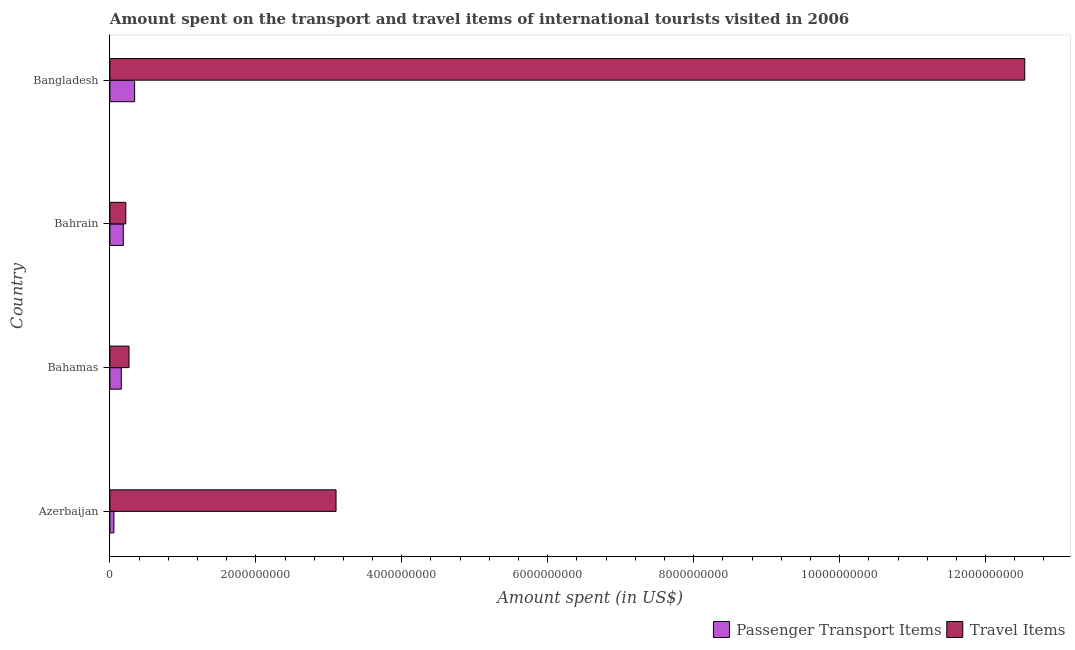How many groups of bars are there?
Provide a short and direct response. 4. Are the number of bars on each tick of the Y-axis equal?
Give a very brief answer. Yes. How many bars are there on the 3rd tick from the top?
Offer a very short reply. 2. How many bars are there on the 3rd tick from the bottom?
Your answer should be very brief. 2. What is the label of the 4th group of bars from the top?
Offer a terse response. Azerbaijan. What is the amount spent on passenger transport items in Bahamas?
Your answer should be very brief. 1.56e+08. Across all countries, what is the maximum amount spent in travel items?
Offer a very short reply. 1.25e+1. Across all countries, what is the minimum amount spent in travel items?
Keep it short and to the point. 2.18e+08. In which country was the amount spent on passenger transport items minimum?
Keep it short and to the point. Azerbaijan. What is the total amount spent on passenger transport items in the graph?
Your answer should be very brief. 7.34e+08. What is the difference between the amount spent in travel items in Azerbaijan and that in Bahamas?
Offer a terse response. 2.84e+09. What is the difference between the amount spent in travel items in Bangladesh and the amount spent on passenger transport items in Bahamas?
Keep it short and to the point. 1.24e+1. What is the average amount spent in travel items per country?
Ensure brevity in your answer.  4.03e+09. What is the difference between the amount spent on passenger transport items and amount spent in travel items in Bahrain?
Give a very brief answer. -3.40e+07. What is the ratio of the amount spent in travel items in Bahamas to that in Bangladesh?
Your answer should be very brief. 0.02. Is the amount spent in travel items in Azerbaijan less than that in Bahamas?
Your response must be concise. No. Is the difference between the amount spent in travel items in Bahamas and Bangladesh greater than the difference between the amount spent on passenger transport items in Bahamas and Bangladesh?
Offer a very short reply. No. What is the difference between the highest and the second highest amount spent in travel items?
Your answer should be very brief. 9.44e+09. What is the difference between the highest and the lowest amount spent on passenger transport items?
Ensure brevity in your answer.  2.84e+08. Is the sum of the amount spent in travel items in Azerbaijan and Bahamas greater than the maximum amount spent on passenger transport items across all countries?
Your answer should be compact. Yes. What does the 1st bar from the top in Bahrain represents?
Provide a short and direct response. Travel Items. What does the 2nd bar from the bottom in Azerbaijan represents?
Your response must be concise. Travel Items. Are all the bars in the graph horizontal?
Ensure brevity in your answer.  Yes. What is the difference between two consecutive major ticks on the X-axis?
Keep it short and to the point. 2.00e+09. Does the graph contain grids?
Provide a succinct answer. No. How are the legend labels stacked?
Make the answer very short. Horizontal. What is the title of the graph?
Provide a succinct answer. Amount spent on the transport and travel items of international tourists visited in 2006. What is the label or title of the X-axis?
Ensure brevity in your answer.  Amount spent (in US$). What is the label or title of the Y-axis?
Your answer should be very brief. Country. What is the Amount spent (in US$) of Passenger Transport Items in Azerbaijan?
Offer a terse response. 5.50e+07. What is the Amount spent (in US$) of Travel Items in Azerbaijan?
Offer a very short reply. 3.10e+09. What is the Amount spent (in US$) in Passenger Transport Items in Bahamas?
Make the answer very short. 1.56e+08. What is the Amount spent (in US$) of Travel Items in Bahamas?
Offer a terse response. 2.62e+08. What is the Amount spent (in US$) in Passenger Transport Items in Bahrain?
Provide a short and direct response. 1.84e+08. What is the Amount spent (in US$) in Travel Items in Bahrain?
Keep it short and to the point. 2.18e+08. What is the Amount spent (in US$) of Passenger Transport Items in Bangladesh?
Make the answer very short. 3.39e+08. What is the Amount spent (in US$) of Travel Items in Bangladesh?
Ensure brevity in your answer.  1.25e+1. Across all countries, what is the maximum Amount spent (in US$) in Passenger Transport Items?
Ensure brevity in your answer.  3.39e+08. Across all countries, what is the maximum Amount spent (in US$) of Travel Items?
Ensure brevity in your answer.  1.25e+1. Across all countries, what is the minimum Amount spent (in US$) of Passenger Transport Items?
Provide a succinct answer. 5.50e+07. Across all countries, what is the minimum Amount spent (in US$) in Travel Items?
Your answer should be compact. 2.18e+08. What is the total Amount spent (in US$) in Passenger Transport Items in the graph?
Give a very brief answer. 7.34e+08. What is the total Amount spent (in US$) of Travel Items in the graph?
Give a very brief answer. 1.61e+1. What is the difference between the Amount spent (in US$) of Passenger Transport Items in Azerbaijan and that in Bahamas?
Your answer should be very brief. -1.01e+08. What is the difference between the Amount spent (in US$) of Travel Items in Azerbaijan and that in Bahamas?
Provide a short and direct response. 2.84e+09. What is the difference between the Amount spent (in US$) in Passenger Transport Items in Azerbaijan and that in Bahrain?
Offer a very short reply. -1.29e+08. What is the difference between the Amount spent (in US$) of Travel Items in Azerbaijan and that in Bahrain?
Your answer should be compact. 2.88e+09. What is the difference between the Amount spent (in US$) of Passenger Transport Items in Azerbaijan and that in Bangladesh?
Your answer should be compact. -2.84e+08. What is the difference between the Amount spent (in US$) of Travel Items in Azerbaijan and that in Bangladesh?
Keep it short and to the point. -9.44e+09. What is the difference between the Amount spent (in US$) in Passenger Transport Items in Bahamas and that in Bahrain?
Your answer should be compact. -2.80e+07. What is the difference between the Amount spent (in US$) of Travel Items in Bahamas and that in Bahrain?
Provide a short and direct response. 4.40e+07. What is the difference between the Amount spent (in US$) in Passenger Transport Items in Bahamas and that in Bangladesh?
Offer a very short reply. -1.83e+08. What is the difference between the Amount spent (in US$) of Travel Items in Bahamas and that in Bangladesh?
Provide a succinct answer. -1.23e+1. What is the difference between the Amount spent (in US$) in Passenger Transport Items in Bahrain and that in Bangladesh?
Make the answer very short. -1.55e+08. What is the difference between the Amount spent (in US$) of Travel Items in Bahrain and that in Bangladesh?
Offer a terse response. -1.23e+1. What is the difference between the Amount spent (in US$) of Passenger Transport Items in Azerbaijan and the Amount spent (in US$) of Travel Items in Bahamas?
Provide a short and direct response. -2.07e+08. What is the difference between the Amount spent (in US$) in Passenger Transport Items in Azerbaijan and the Amount spent (in US$) in Travel Items in Bahrain?
Your response must be concise. -1.63e+08. What is the difference between the Amount spent (in US$) of Passenger Transport Items in Azerbaijan and the Amount spent (in US$) of Travel Items in Bangladesh?
Keep it short and to the point. -1.25e+1. What is the difference between the Amount spent (in US$) in Passenger Transport Items in Bahamas and the Amount spent (in US$) in Travel Items in Bahrain?
Keep it short and to the point. -6.20e+07. What is the difference between the Amount spent (in US$) of Passenger Transport Items in Bahamas and the Amount spent (in US$) of Travel Items in Bangladesh?
Give a very brief answer. -1.24e+1. What is the difference between the Amount spent (in US$) in Passenger Transport Items in Bahrain and the Amount spent (in US$) in Travel Items in Bangladesh?
Give a very brief answer. -1.24e+1. What is the average Amount spent (in US$) in Passenger Transport Items per country?
Your answer should be very brief. 1.84e+08. What is the average Amount spent (in US$) in Travel Items per country?
Your answer should be compact. 4.03e+09. What is the difference between the Amount spent (in US$) in Passenger Transport Items and Amount spent (in US$) in Travel Items in Azerbaijan?
Give a very brief answer. -3.04e+09. What is the difference between the Amount spent (in US$) of Passenger Transport Items and Amount spent (in US$) of Travel Items in Bahamas?
Provide a succinct answer. -1.06e+08. What is the difference between the Amount spent (in US$) of Passenger Transport Items and Amount spent (in US$) of Travel Items in Bahrain?
Provide a short and direct response. -3.40e+07. What is the difference between the Amount spent (in US$) in Passenger Transport Items and Amount spent (in US$) in Travel Items in Bangladesh?
Keep it short and to the point. -1.22e+1. What is the ratio of the Amount spent (in US$) of Passenger Transport Items in Azerbaijan to that in Bahamas?
Offer a terse response. 0.35. What is the ratio of the Amount spent (in US$) in Travel Items in Azerbaijan to that in Bahamas?
Offer a terse response. 11.83. What is the ratio of the Amount spent (in US$) in Passenger Transport Items in Azerbaijan to that in Bahrain?
Give a very brief answer. 0.3. What is the ratio of the Amount spent (in US$) in Travel Items in Azerbaijan to that in Bahrain?
Offer a terse response. 14.22. What is the ratio of the Amount spent (in US$) of Passenger Transport Items in Azerbaijan to that in Bangladesh?
Keep it short and to the point. 0.16. What is the ratio of the Amount spent (in US$) of Travel Items in Azerbaijan to that in Bangladesh?
Your answer should be compact. 0.25. What is the ratio of the Amount spent (in US$) in Passenger Transport Items in Bahamas to that in Bahrain?
Keep it short and to the point. 0.85. What is the ratio of the Amount spent (in US$) in Travel Items in Bahamas to that in Bahrain?
Make the answer very short. 1.2. What is the ratio of the Amount spent (in US$) in Passenger Transport Items in Bahamas to that in Bangladesh?
Your answer should be compact. 0.46. What is the ratio of the Amount spent (in US$) of Travel Items in Bahamas to that in Bangladesh?
Provide a succinct answer. 0.02. What is the ratio of the Amount spent (in US$) of Passenger Transport Items in Bahrain to that in Bangladesh?
Your response must be concise. 0.54. What is the ratio of the Amount spent (in US$) of Travel Items in Bahrain to that in Bangladesh?
Provide a succinct answer. 0.02. What is the difference between the highest and the second highest Amount spent (in US$) in Passenger Transport Items?
Keep it short and to the point. 1.55e+08. What is the difference between the highest and the second highest Amount spent (in US$) in Travel Items?
Ensure brevity in your answer.  9.44e+09. What is the difference between the highest and the lowest Amount spent (in US$) in Passenger Transport Items?
Provide a short and direct response. 2.84e+08. What is the difference between the highest and the lowest Amount spent (in US$) of Travel Items?
Offer a terse response. 1.23e+1. 